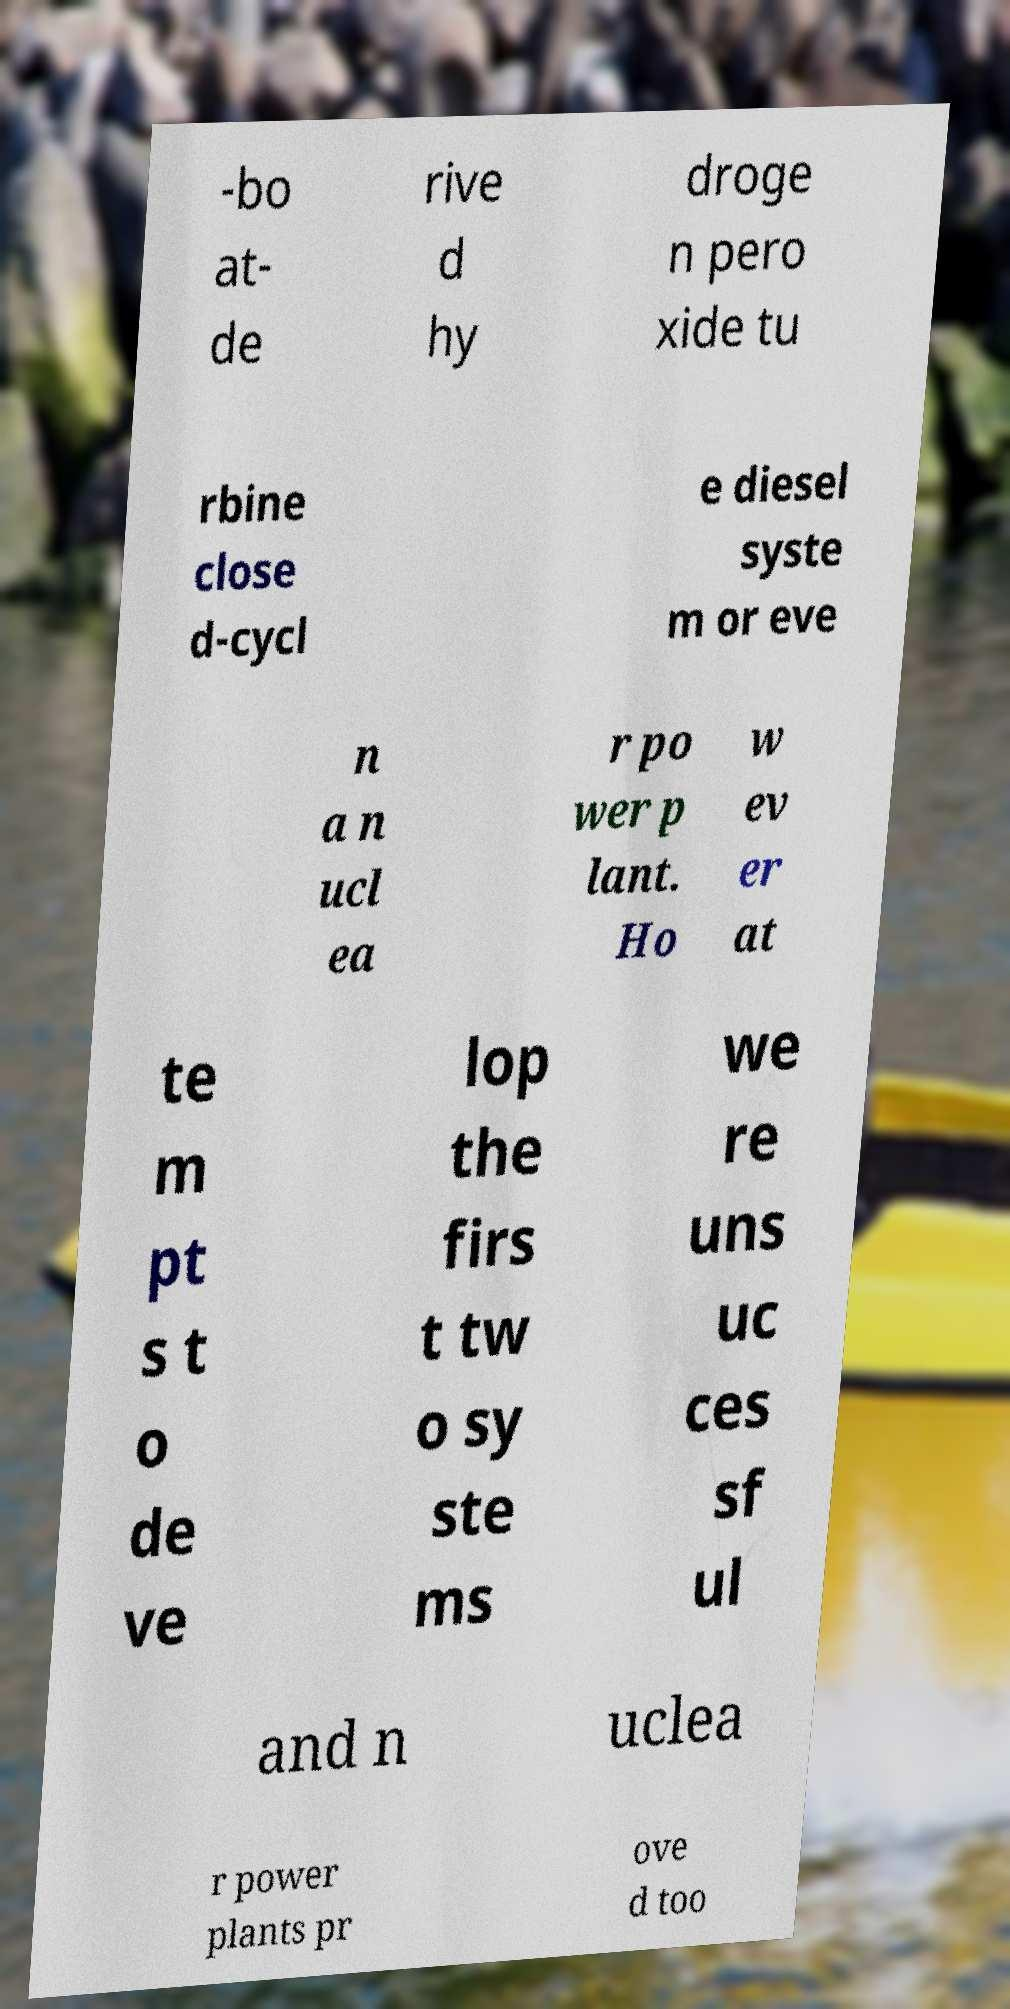Could you assist in decoding the text presented in this image and type it out clearly? -bo at- de rive d hy droge n pero xide tu rbine close d-cycl e diesel syste m or eve n a n ucl ea r po wer p lant. Ho w ev er at te m pt s t o de ve lop the firs t tw o sy ste ms we re uns uc ces sf ul and n uclea r power plants pr ove d too 